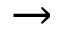<formula> <loc_0><loc_0><loc_500><loc_500>\to</formula> 